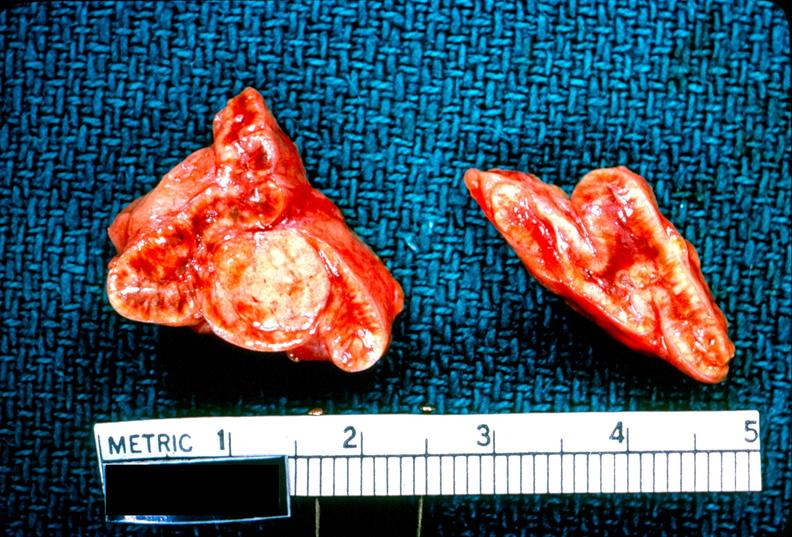s endocrine present?
Answer the question using a single word or phrase. Yes 